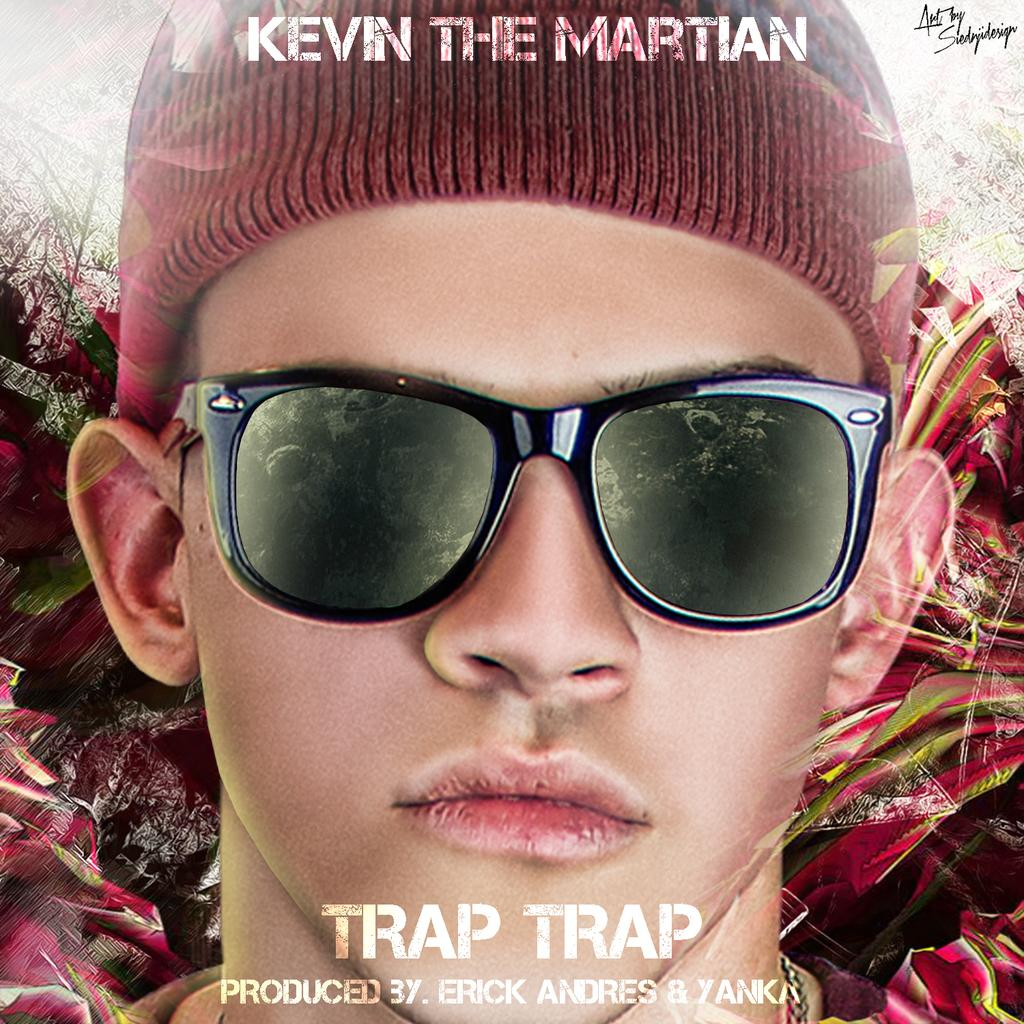<image>
Relay a brief, clear account of the picture shown. Cover showing a boy with sunglasses and the name Trap Trap. 